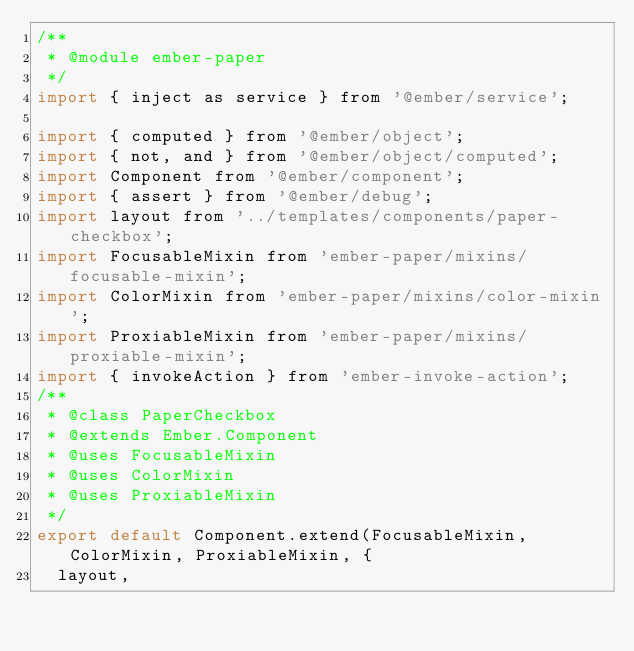<code> <loc_0><loc_0><loc_500><loc_500><_JavaScript_>/**
 * @module ember-paper
 */
import { inject as service } from '@ember/service';

import { computed } from '@ember/object';
import { not, and } from '@ember/object/computed';
import Component from '@ember/component';
import { assert } from '@ember/debug';
import layout from '../templates/components/paper-checkbox';
import FocusableMixin from 'ember-paper/mixins/focusable-mixin';
import ColorMixin from 'ember-paper/mixins/color-mixin';
import ProxiableMixin from 'ember-paper/mixins/proxiable-mixin';
import { invokeAction } from 'ember-invoke-action';
/**
 * @class PaperCheckbox
 * @extends Ember.Component
 * @uses FocusableMixin
 * @uses ColorMixin
 * @uses ProxiableMixin
 */
export default Component.extend(FocusableMixin, ColorMixin, ProxiableMixin, {
  layout,</code> 